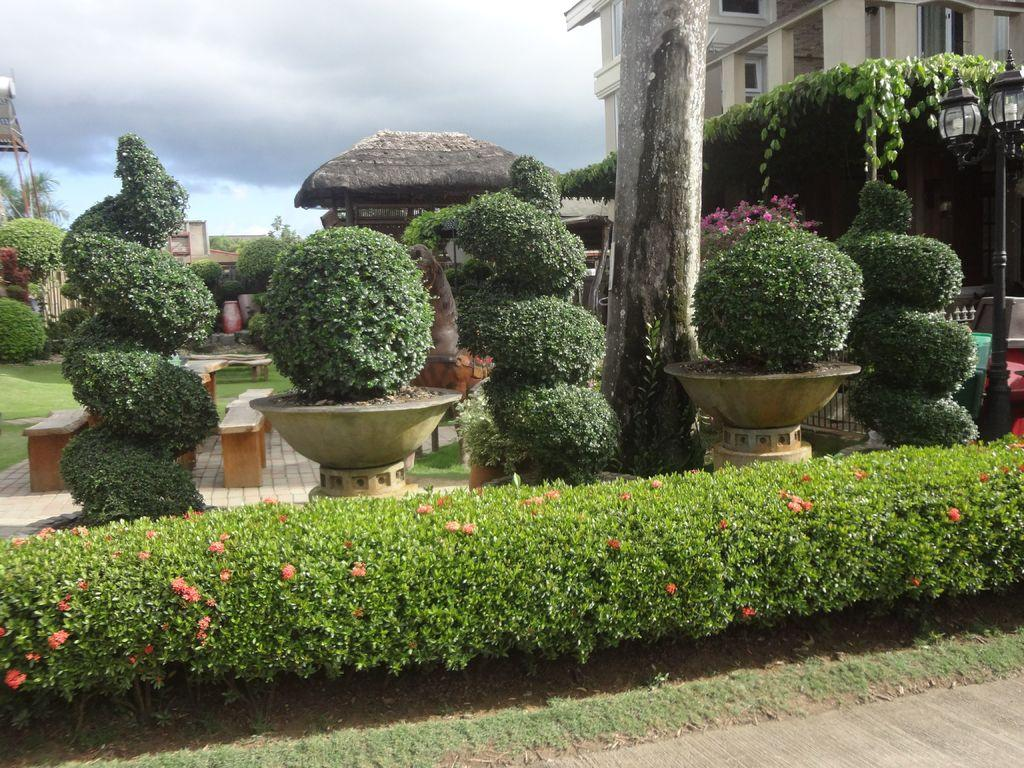What type of living organisms can be seen in the image? Plants can be seen in the image. What can be seen in the background of the image? There is a building and the sky visible in the background of the image. What book is the person reading in the image? There is no person or book present in the image; it features plants and a background with a building and the sky. 